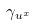Convert formula to latex. <formula><loc_0><loc_0><loc_500><loc_500>\gamma _ { u ^ { x } }</formula> 